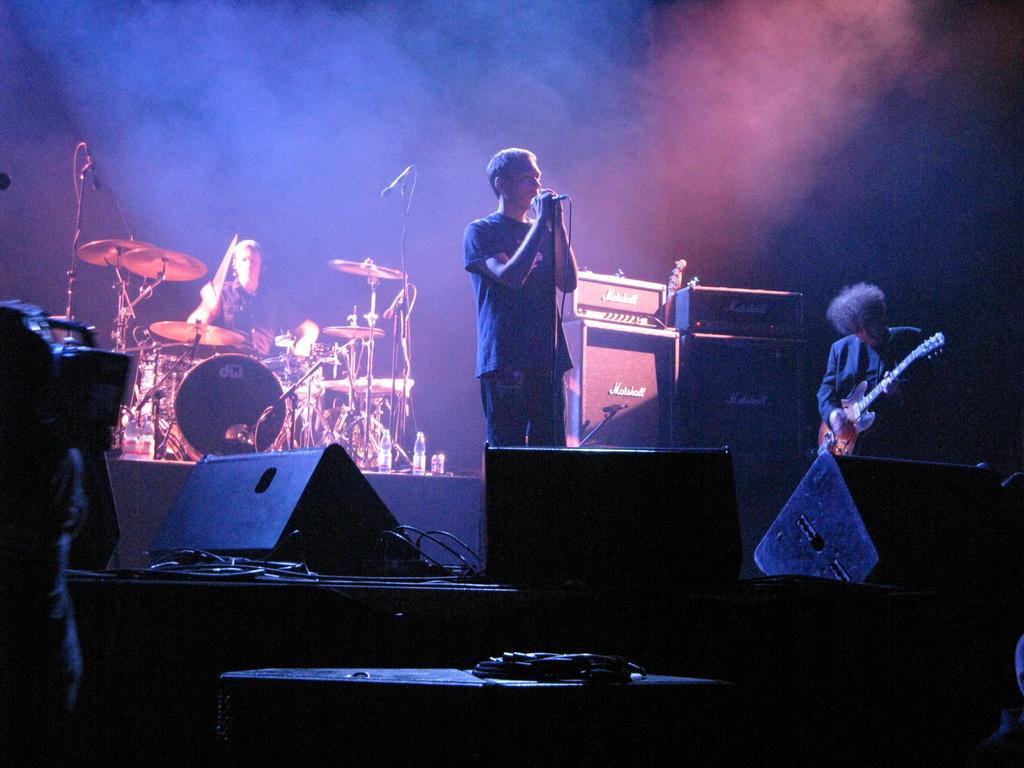In one or two sentences, can you explain what this image depicts? In this picture there is a man standing and singing. There is a man who is sitting and playing guitar. There is a person sitting on the chair. There is a mic and other musical instruments. There is a man holding a camera. There is a mic and wire. 